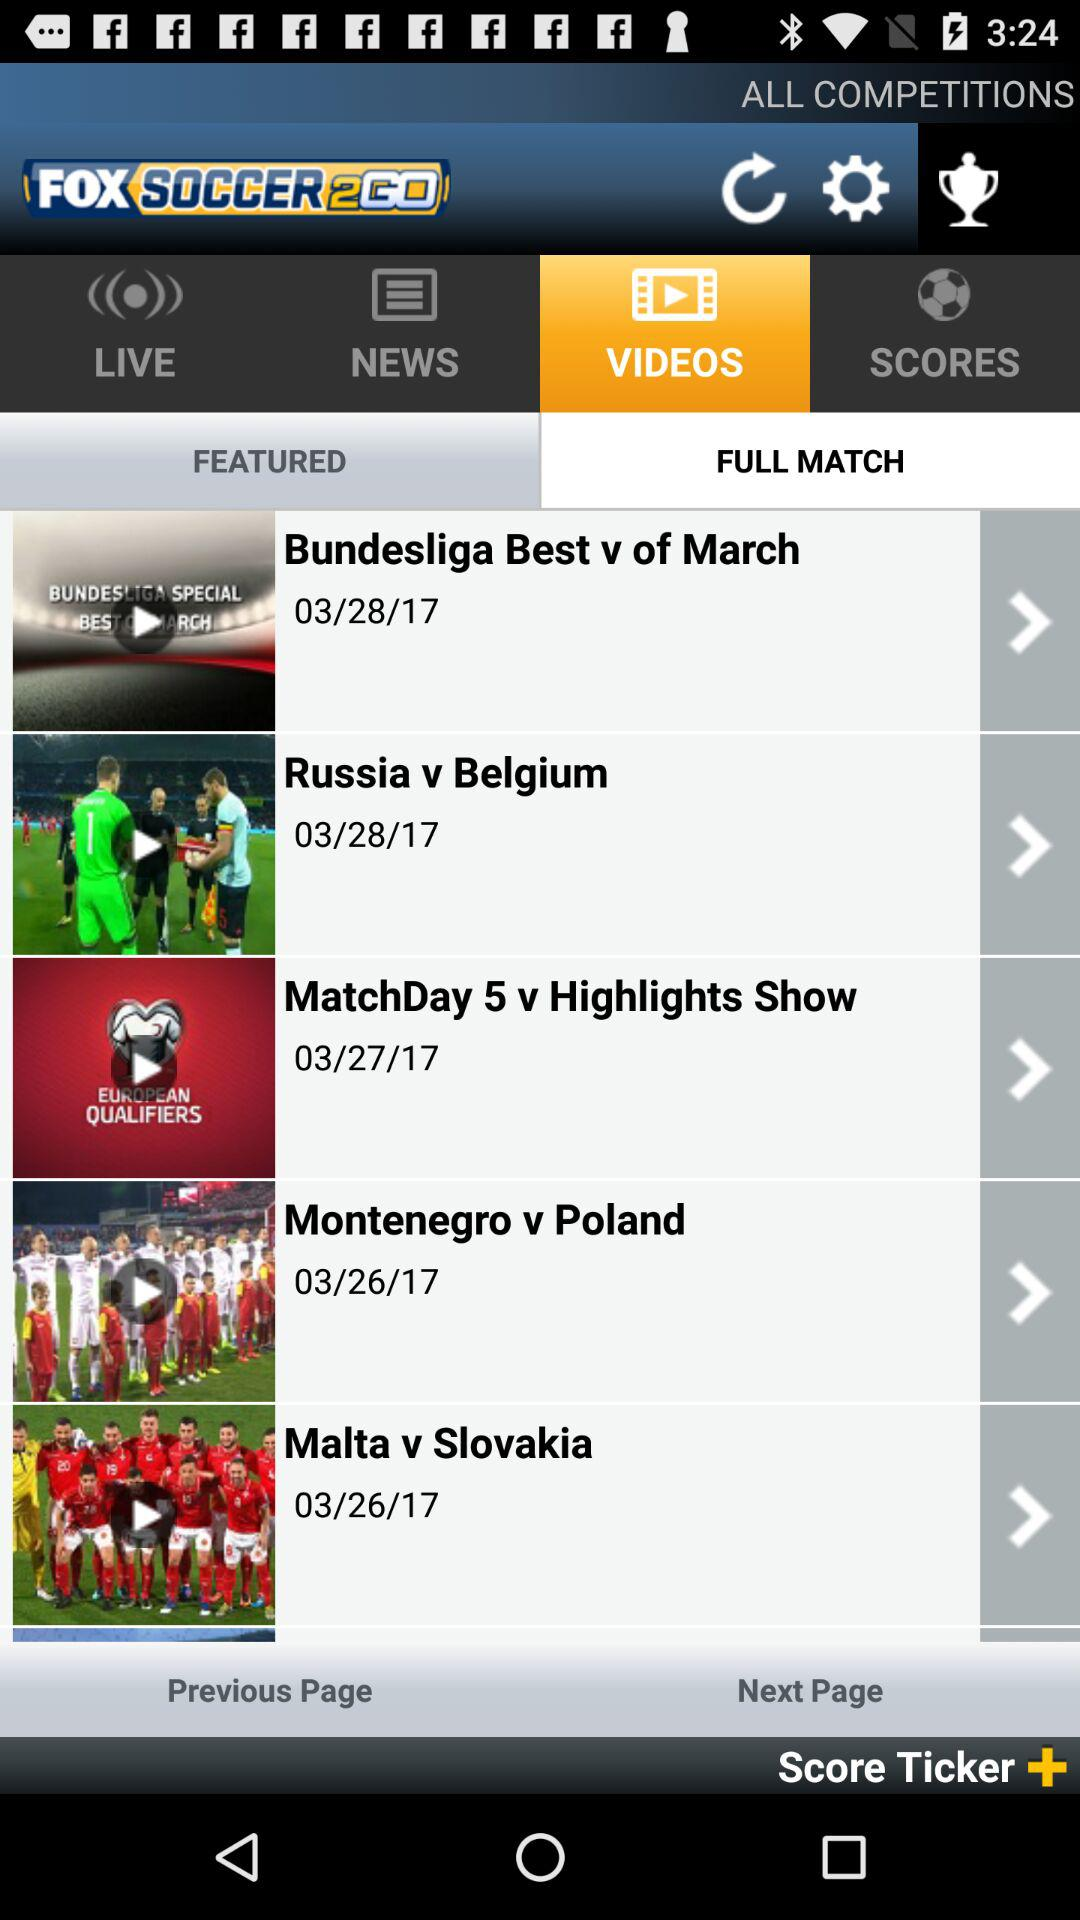On what date was the video of the match "Russia v Belgium" posted? The video was posted on March 28, 2017. 